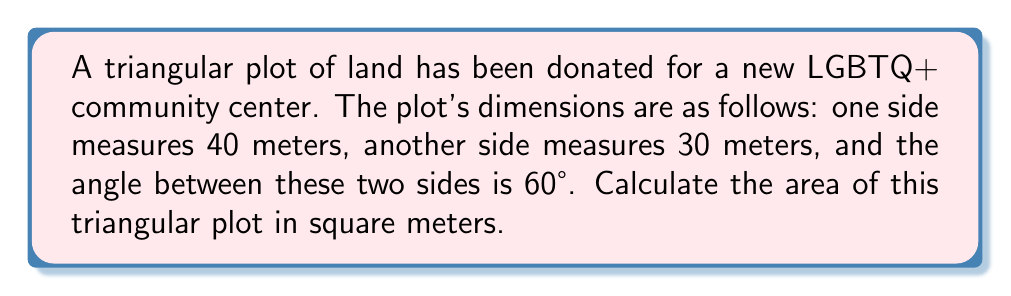Can you solve this math problem? To find the area of this triangular plot, we can use the formula for the area of a triangle given two sides and the included angle:

$$ A = \frac{1}{2} ab \sin(C) $$

Where:
$A$ = Area of the triangle
$a$ and $b$ = Lengths of the two known sides
$C$ = Angle between the two known sides

Given:
$a = 40$ meters
$b = 30$ meters
$C = 60°$

Step 1: Substitute the values into the formula
$$ A = \frac{1}{2} (40)(30) \sin(60°) $$

Step 2: Evaluate $\sin(60°)$
$\sin(60°) = \frac{\sqrt{3}}{2}$

Step 3: Substitute this value and calculate
$$ A = \frac{1}{2} (40)(30) (\frac{\sqrt{3}}{2}) $$
$$ A = 300 \cdot \frac{\sqrt{3}}{2} $$
$$ A = 150\sqrt{3} $$

Step 4: Calculate the approximate value
$A \approx 259.81$ square meters

Therefore, the area of the triangular plot for the LGBTQ+ community center is $150\sqrt{3}$ square meters, or approximately 259.81 square meters.
Answer: $150\sqrt{3}$ m² 